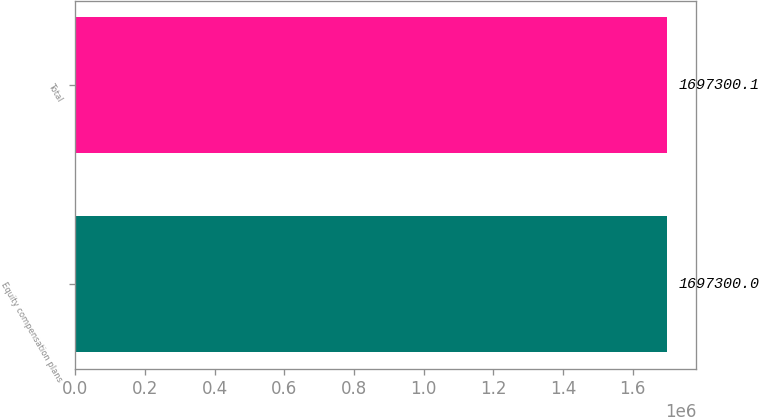Convert chart to OTSL. <chart><loc_0><loc_0><loc_500><loc_500><bar_chart><fcel>Equity compensation plans<fcel>Total<nl><fcel>1.6973e+06<fcel>1.6973e+06<nl></chart> 